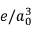<formula> <loc_0><loc_0><loc_500><loc_500>e / a _ { 0 } ^ { 3 }</formula> 